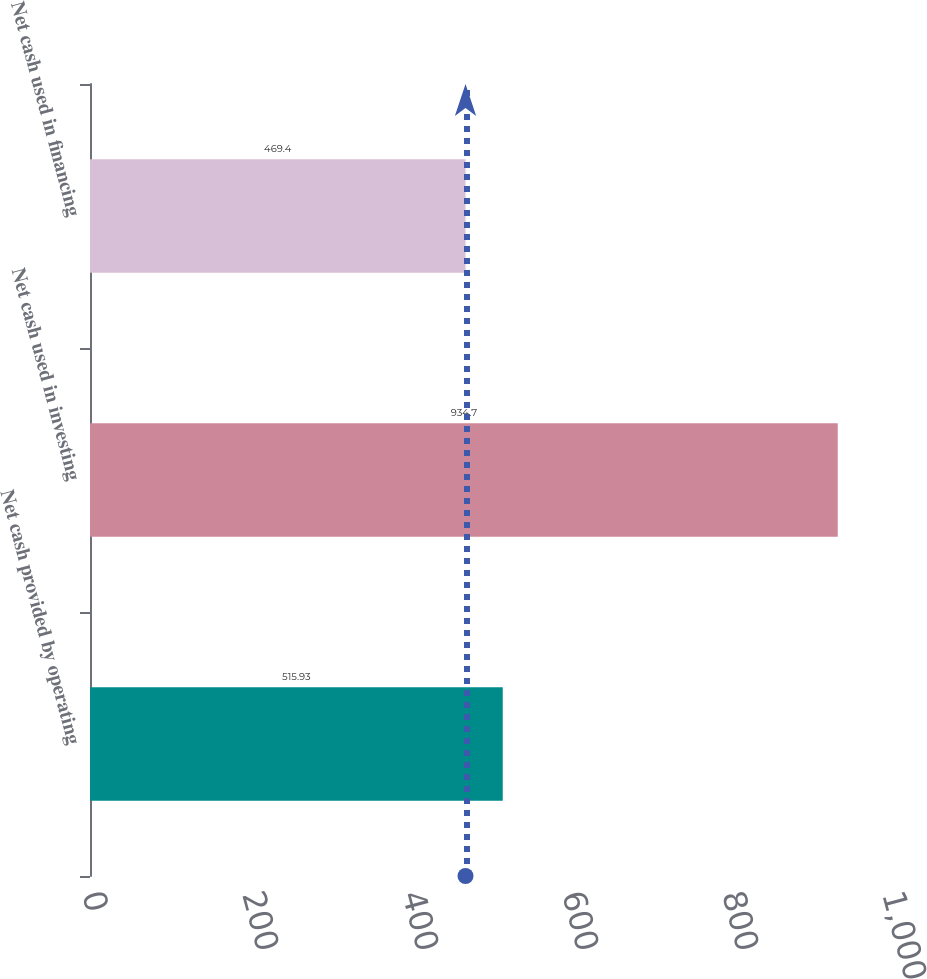Convert chart to OTSL. <chart><loc_0><loc_0><loc_500><loc_500><bar_chart><fcel>Net cash provided by operating<fcel>Net cash used in investing<fcel>Net cash used in financing<nl><fcel>515.93<fcel>934.7<fcel>469.4<nl></chart> 